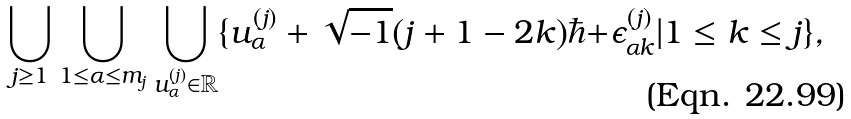Convert formula to latex. <formula><loc_0><loc_0><loc_500><loc_500>\bigcup _ { j \geq 1 } \bigcup _ { 1 \leq \alpha \leq m _ { j } } \bigcup _ { u ^ { ( j ) } _ { \alpha } \in { \mathbb { R } } } \{ u ^ { ( j ) } _ { \alpha } + \sqrt { - 1 } ( j + 1 - 2 k ) \hbar { + } \epsilon ^ { ( j ) } _ { \alpha k } | 1 \leq k \leq j \} ,</formula> 